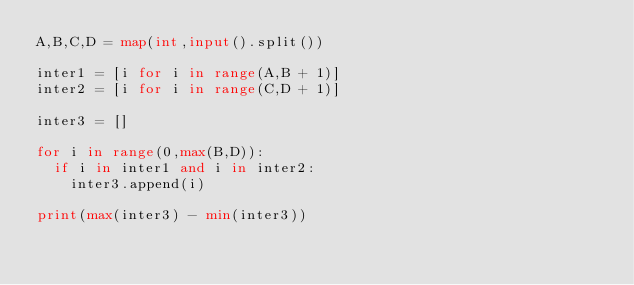Convert code to text. <code><loc_0><loc_0><loc_500><loc_500><_Python_>A,B,C,D = map(int,input().split())

inter1 = [i for i in range(A,B + 1)]
inter2 = [i for i in range(C,D + 1)]

inter3 = []

for i in range(0,max(B,D)):
  if i in inter1 and i in inter2:
    inter3.append(i)
    
print(max(inter3) - min(inter3))</code> 